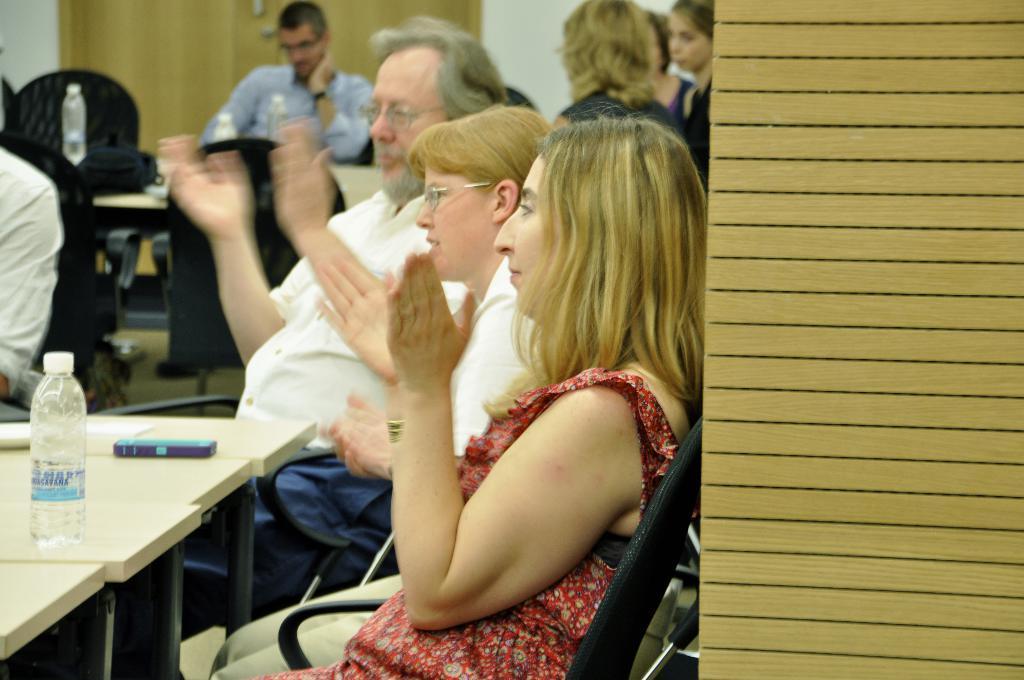How would you summarize this image in a sentence or two? In this picture we can see some people were sitting on chair and clapping hands and in front of them there is table and on table we can see bottle, box, bag and in background we can see door, wall. 